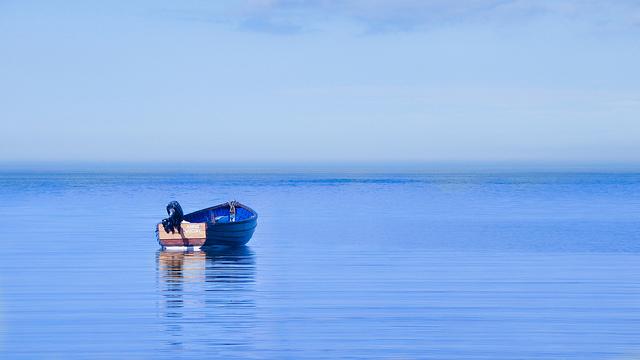Is the ocean blue?
Answer briefly. Yes. What is the purpose of the only man made object in this photo?
Keep it brief. To float on water. What is in the water?
Quick response, please. Boat. Is the water calm?
Keep it brief. Yes. Is anyone inside the boat?
Keep it brief. No. 